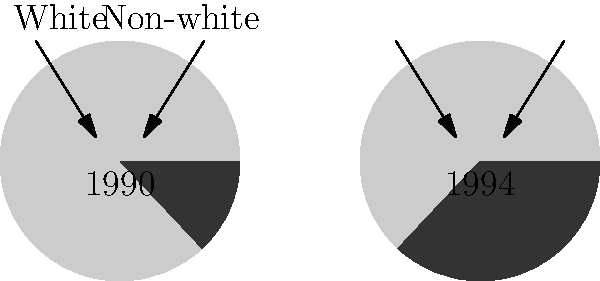Based on the pie charts showing the racial composition of the South African parliament in 1990 and 1994, what was the approximate percentage increase in non-white representation after Mandela's election as President? To calculate the percentage increase in non-white representation, we need to follow these steps:

1. Identify the non-white representation percentages:
   - In 1990 (before Mandela's presidency): 13%
   - In 1994 (after Mandela's election): 37%

2. Calculate the difference in percentage points:
   $37\% - 13\% = 24\%$ percentage points

3. Calculate the percentage increase:
   Percentage increase = $\frac{\text{Increase}}{\text{Original Value}} \times 100\%$
   $= \frac{24}{13} \times 100\% \approx 184.62\%$

Therefore, the non-white representation in the South African parliament increased by approximately 185% after Mandela's election as President in 1994.
Answer: 185% 